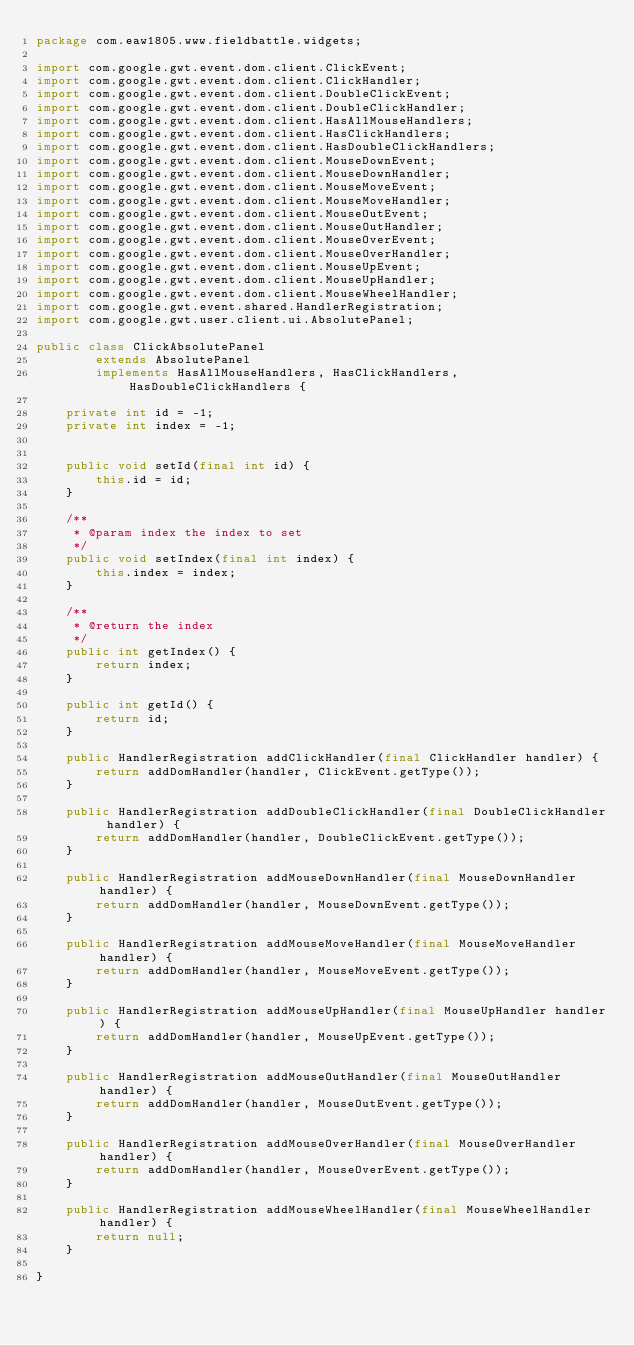<code> <loc_0><loc_0><loc_500><loc_500><_Java_>package com.eaw1805.www.fieldbattle.widgets;

import com.google.gwt.event.dom.client.ClickEvent;
import com.google.gwt.event.dom.client.ClickHandler;
import com.google.gwt.event.dom.client.DoubleClickEvent;
import com.google.gwt.event.dom.client.DoubleClickHandler;
import com.google.gwt.event.dom.client.HasAllMouseHandlers;
import com.google.gwt.event.dom.client.HasClickHandlers;
import com.google.gwt.event.dom.client.HasDoubleClickHandlers;
import com.google.gwt.event.dom.client.MouseDownEvent;
import com.google.gwt.event.dom.client.MouseDownHandler;
import com.google.gwt.event.dom.client.MouseMoveEvent;
import com.google.gwt.event.dom.client.MouseMoveHandler;
import com.google.gwt.event.dom.client.MouseOutEvent;
import com.google.gwt.event.dom.client.MouseOutHandler;
import com.google.gwt.event.dom.client.MouseOverEvent;
import com.google.gwt.event.dom.client.MouseOverHandler;
import com.google.gwt.event.dom.client.MouseUpEvent;
import com.google.gwt.event.dom.client.MouseUpHandler;
import com.google.gwt.event.dom.client.MouseWheelHandler;
import com.google.gwt.event.shared.HandlerRegistration;
import com.google.gwt.user.client.ui.AbsolutePanel;

public class ClickAbsolutePanel
        extends AbsolutePanel
        implements HasAllMouseHandlers, HasClickHandlers, HasDoubleClickHandlers {

    private int id = -1;
    private int index = -1;


    public void setId(final int id) {
        this.id = id;
    }

    /**
     * @param index the index to set
     */
    public void setIndex(final int index) {
        this.index = index;
    }

    /**
     * @return the index
     */
    public int getIndex() {
        return index;
    }

    public int getId() {
        return id;
    }

    public HandlerRegistration addClickHandler(final ClickHandler handler) {
        return addDomHandler(handler, ClickEvent.getType());
    }

    public HandlerRegistration addDoubleClickHandler(final DoubleClickHandler handler) {
        return addDomHandler(handler, DoubleClickEvent.getType());
    }

    public HandlerRegistration addMouseDownHandler(final MouseDownHandler handler) {
        return addDomHandler(handler, MouseDownEvent.getType());
    }

    public HandlerRegistration addMouseMoveHandler(final MouseMoveHandler handler) {
        return addDomHandler(handler, MouseMoveEvent.getType());
    }

    public HandlerRegistration addMouseUpHandler(final MouseUpHandler handler) {
        return addDomHandler(handler, MouseUpEvent.getType());
    }

    public HandlerRegistration addMouseOutHandler(final MouseOutHandler handler) {
        return addDomHandler(handler, MouseOutEvent.getType());
    }

    public HandlerRegistration addMouseOverHandler(final MouseOverHandler handler) {
        return addDomHandler(handler, MouseOverEvent.getType());
    }

    public HandlerRegistration addMouseWheelHandler(final MouseWheelHandler handler) {
        return null;
    }

}
</code> 